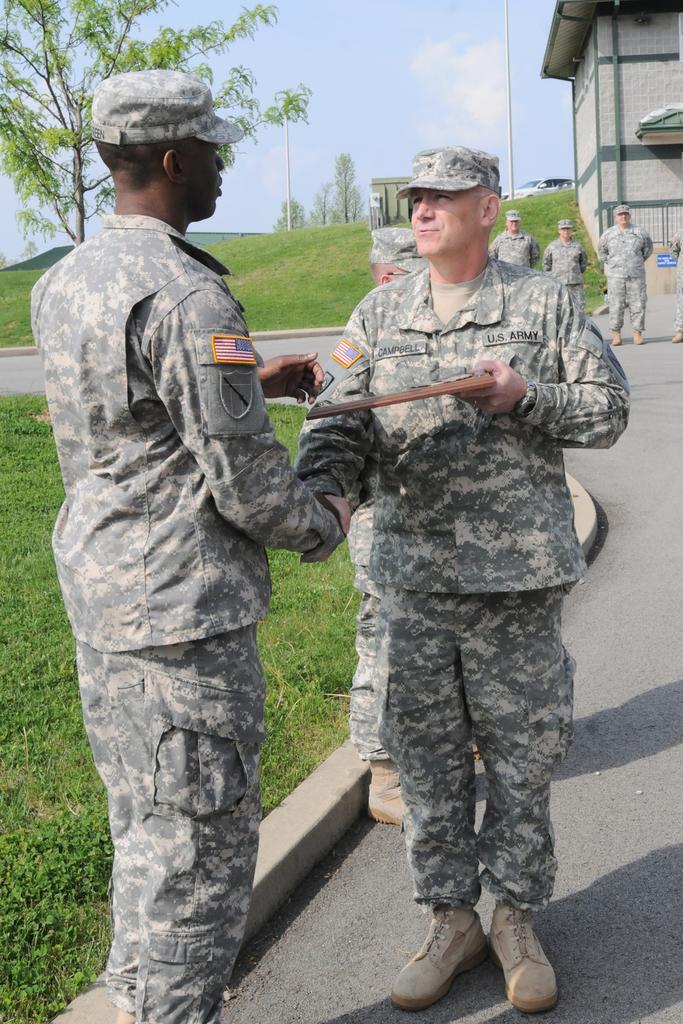Please provide a concise description of this image. In this picture there are two military person holding their hand and talking. Behind there is a group of military man standing and watching them. In the background there is a grey color small house and grass hill with some trees. 